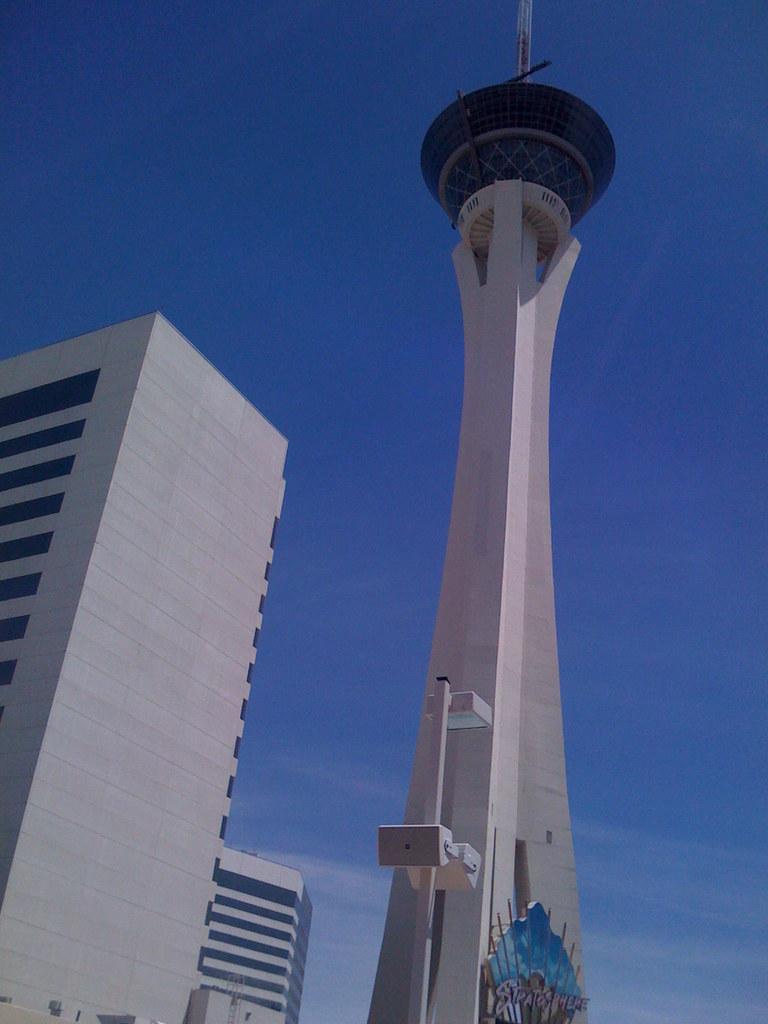Could you give a brief overview of what you see in this image? In this image we can see a tower on which there is helipad and buildings top of the image there is clear sky. 